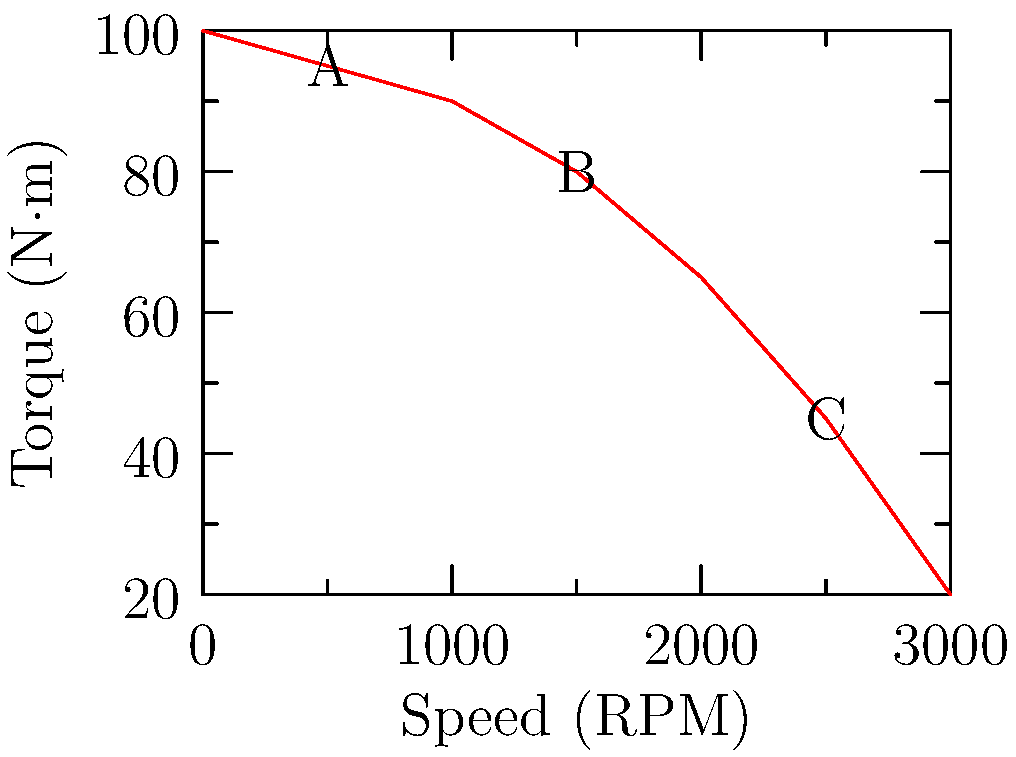In the torque-speed characteristic curve of an electric motor used in a hybrid system, three points A, B, and C are marked. If the motor is operating at point B, what change in the motor's operation would move it to point A, and how would this affect the vehicle's performance? To answer this question, let's analyze the torque-speed characteristic curve step-by-step:

1. Point B is at approximately 1500 RPM and 80 N·m of torque.
2. Point A is at approximately 500 RPM and 95 N·m of torque.

To move from B to A:
3. The motor speed needs to decrease from 1500 RPM to 500 RPM.
4. The motor torque needs to increase from 80 N·m to 95 N·m.

This change can be achieved by:
5. Increasing the load on the motor or reducing the voltage applied to the motor.

Effect on vehicle performance:
6. Lower speed: The vehicle will move slower as the motor RPM decreases.
7. Higher torque: The vehicle will have more pulling power, useful for acceleration or climbing hills.
8. Increased efficiency: Electric motors are often more efficient at lower speeds and higher torques.
9. Better low-speed control: Useful for precise maneuvering or slow-speed operations.

In a hybrid system:
10. This change might occur when transitioning from highway cruising to city driving or when additional power is needed for acceleration.
11. The internal combustion engine might engage to compensate for the reduced speed while taking advantage of the electric motor's increased torque.
Answer: Increase load or reduce voltage; slower speed but higher torque and efficiency 